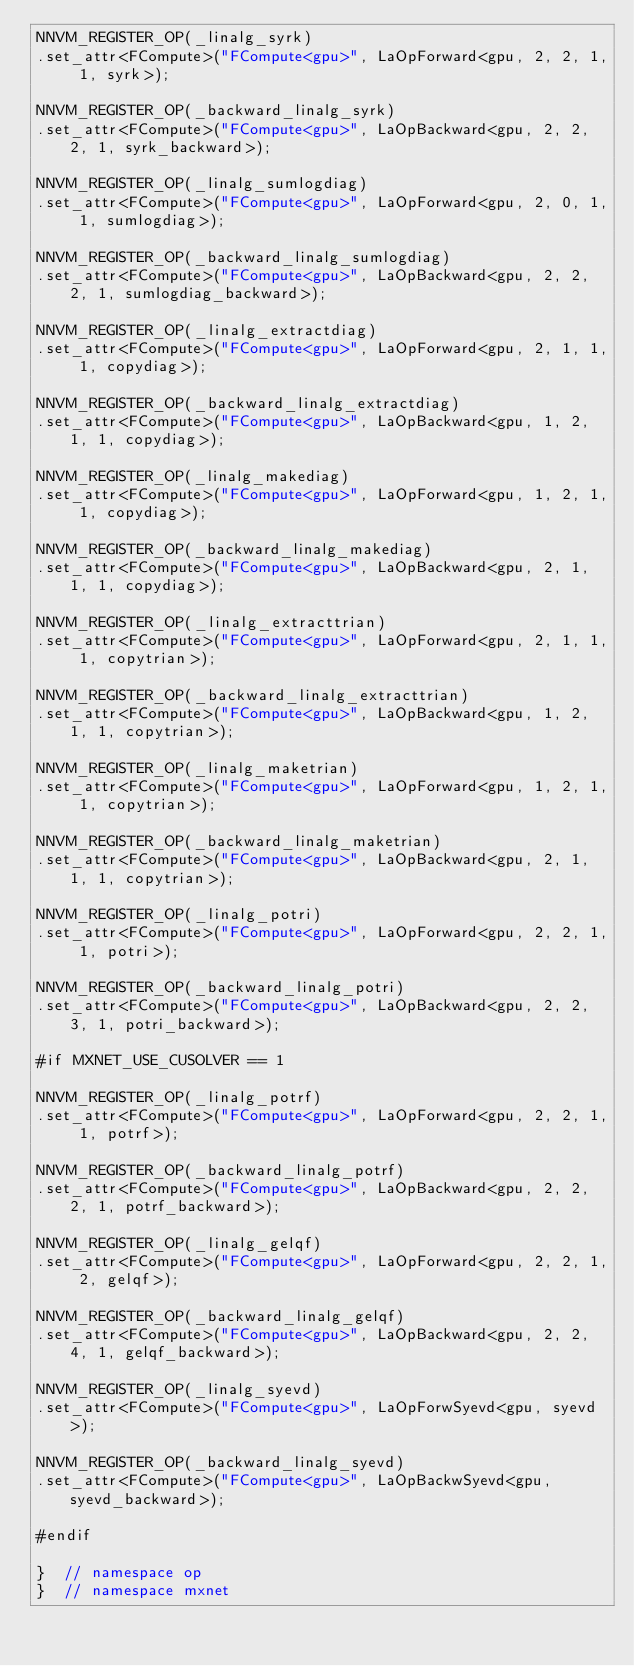<code> <loc_0><loc_0><loc_500><loc_500><_Cuda_>NNVM_REGISTER_OP(_linalg_syrk)
.set_attr<FCompute>("FCompute<gpu>", LaOpForward<gpu, 2, 2, 1, 1, syrk>);

NNVM_REGISTER_OP(_backward_linalg_syrk)
.set_attr<FCompute>("FCompute<gpu>", LaOpBackward<gpu, 2, 2, 2, 1, syrk_backward>);

NNVM_REGISTER_OP(_linalg_sumlogdiag)
.set_attr<FCompute>("FCompute<gpu>", LaOpForward<gpu, 2, 0, 1, 1, sumlogdiag>);

NNVM_REGISTER_OP(_backward_linalg_sumlogdiag)
.set_attr<FCompute>("FCompute<gpu>", LaOpBackward<gpu, 2, 2, 2, 1, sumlogdiag_backward>);

NNVM_REGISTER_OP(_linalg_extractdiag)
.set_attr<FCompute>("FCompute<gpu>", LaOpForward<gpu, 2, 1, 1, 1, copydiag>);

NNVM_REGISTER_OP(_backward_linalg_extractdiag)
.set_attr<FCompute>("FCompute<gpu>", LaOpBackward<gpu, 1, 2, 1, 1, copydiag>);

NNVM_REGISTER_OP(_linalg_makediag)
.set_attr<FCompute>("FCompute<gpu>", LaOpForward<gpu, 1, 2, 1, 1, copydiag>);

NNVM_REGISTER_OP(_backward_linalg_makediag)
.set_attr<FCompute>("FCompute<gpu>", LaOpBackward<gpu, 2, 1, 1, 1, copydiag>);

NNVM_REGISTER_OP(_linalg_extracttrian)
.set_attr<FCompute>("FCompute<gpu>", LaOpForward<gpu, 2, 1, 1, 1, copytrian>);

NNVM_REGISTER_OP(_backward_linalg_extracttrian)
.set_attr<FCompute>("FCompute<gpu>", LaOpBackward<gpu, 1, 2, 1, 1, copytrian>);

NNVM_REGISTER_OP(_linalg_maketrian)
.set_attr<FCompute>("FCompute<gpu>", LaOpForward<gpu, 1, 2, 1, 1, copytrian>);

NNVM_REGISTER_OP(_backward_linalg_maketrian)
.set_attr<FCompute>("FCompute<gpu>", LaOpBackward<gpu, 2, 1, 1, 1, copytrian>);

NNVM_REGISTER_OP(_linalg_potri)
.set_attr<FCompute>("FCompute<gpu>", LaOpForward<gpu, 2, 2, 1, 1, potri>);

NNVM_REGISTER_OP(_backward_linalg_potri)
.set_attr<FCompute>("FCompute<gpu>", LaOpBackward<gpu, 2, 2, 3, 1, potri_backward>);

#if MXNET_USE_CUSOLVER == 1

NNVM_REGISTER_OP(_linalg_potrf)
.set_attr<FCompute>("FCompute<gpu>", LaOpForward<gpu, 2, 2, 1, 1, potrf>);

NNVM_REGISTER_OP(_backward_linalg_potrf)
.set_attr<FCompute>("FCompute<gpu>", LaOpBackward<gpu, 2, 2, 2, 1, potrf_backward>);

NNVM_REGISTER_OP(_linalg_gelqf)
.set_attr<FCompute>("FCompute<gpu>", LaOpForward<gpu, 2, 2, 1, 2, gelqf>);

NNVM_REGISTER_OP(_backward_linalg_gelqf)
.set_attr<FCompute>("FCompute<gpu>", LaOpBackward<gpu, 2, 2, 4, 1, gelqf_backward>);

NNVM_REGISTER_OP(_linalg_syevd)
.set_attr<FCompute>("FCompute<gpu>", LaOpForwSyevd<gpu, syevd>);

NNVM_REGISTER_OP(_backward_linalg_syevd)
.set_attr<FCompute>("FCompute<gpu>", LaOpBackwSyevd<gpu, syevd_backward>);

#endif

}  // namespace op
}  // namespace mxnet
</code> 